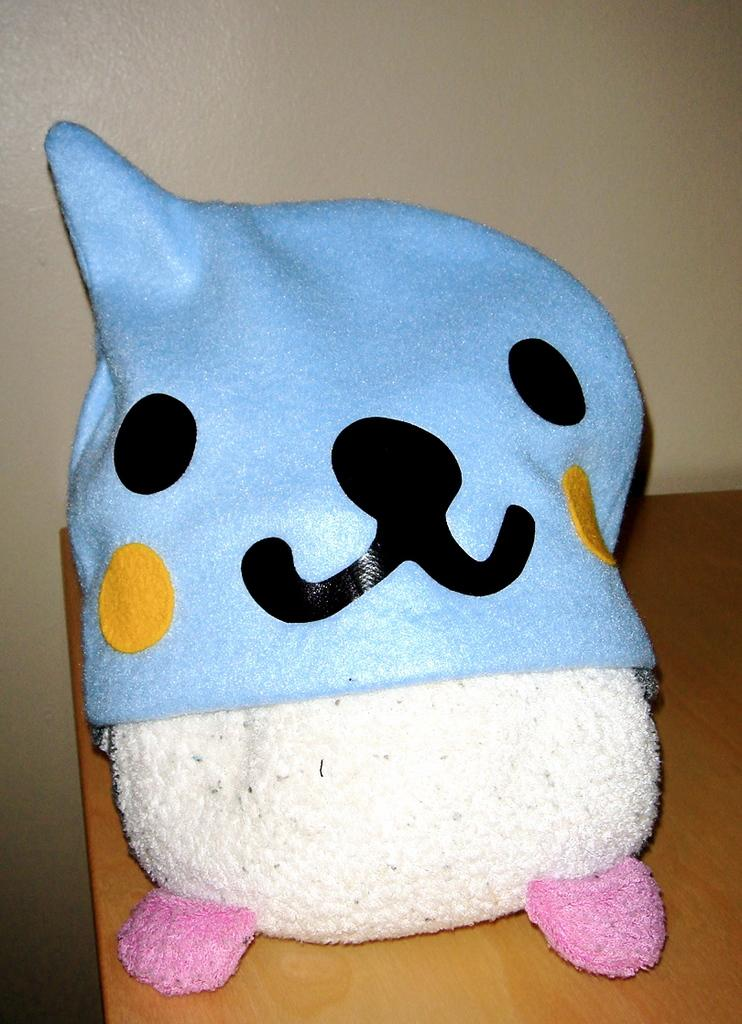What object is placed on the table in the image? There is a toy on the table in the image. What can be seen in the background of the image? There is a wall in the background of the image. How many tomatoes are hanging from the toy in the image? There are no tomatoes present in the image, and therefore no tomatoes are hanging from the toy. 